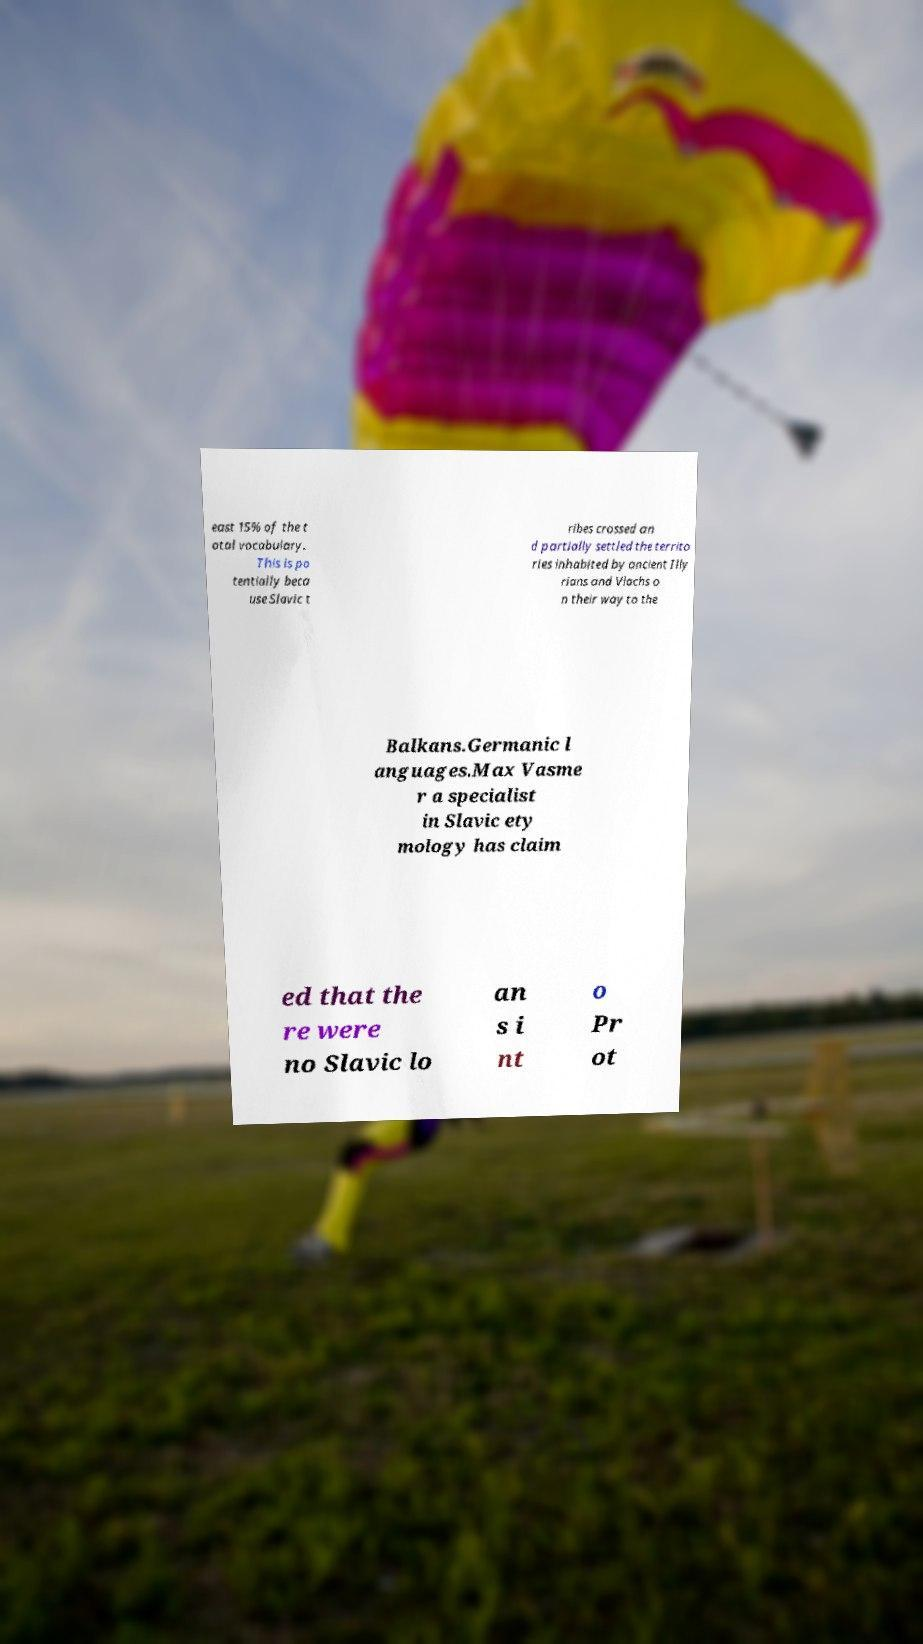Please read and relay the text visible in this image. What does it say? east 15% of the t otal vocabulary. This is po tentially beca use Slavic t ribes crossed an d partially settled the territo ries inhabited by ancient Illy rians and Vlachs o n their way to the Balkans.Germanic l anguages.Max Vasme r a specialist in Slavic ety mology has claim ed that the re were no Slavic lo an s i nt o Pr ot 